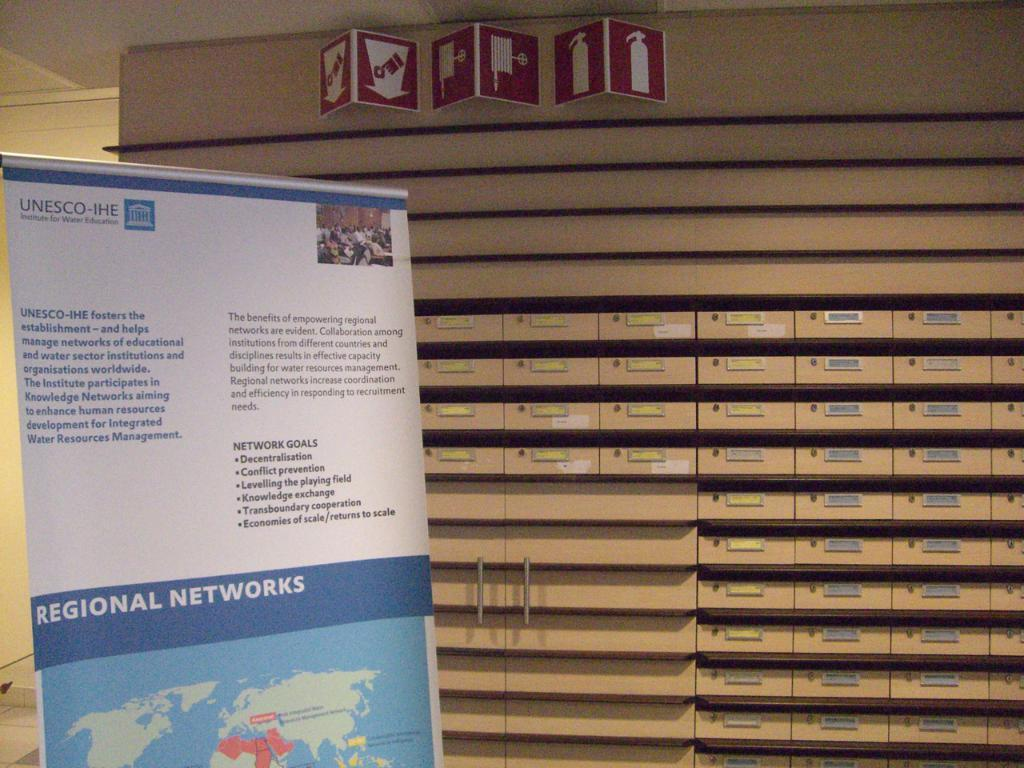<image>
Summarize the visual content of the image. A UNESCO panel showing the regional networks map. 